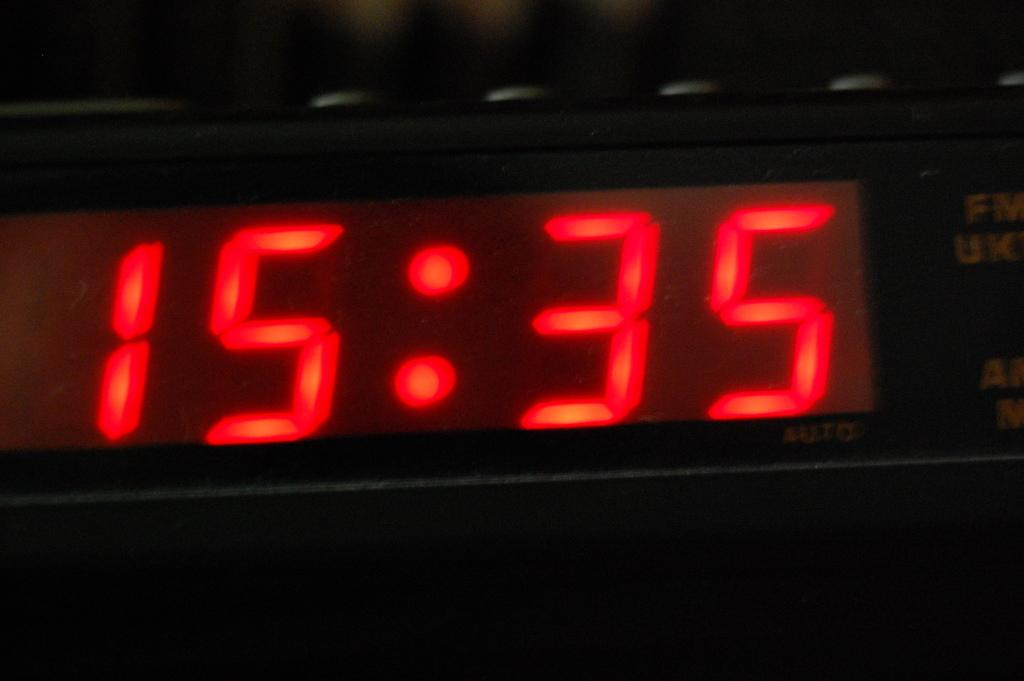<image>
Create a compact narrative representing the image presented. A close up of a digital clock showing 15:35. 